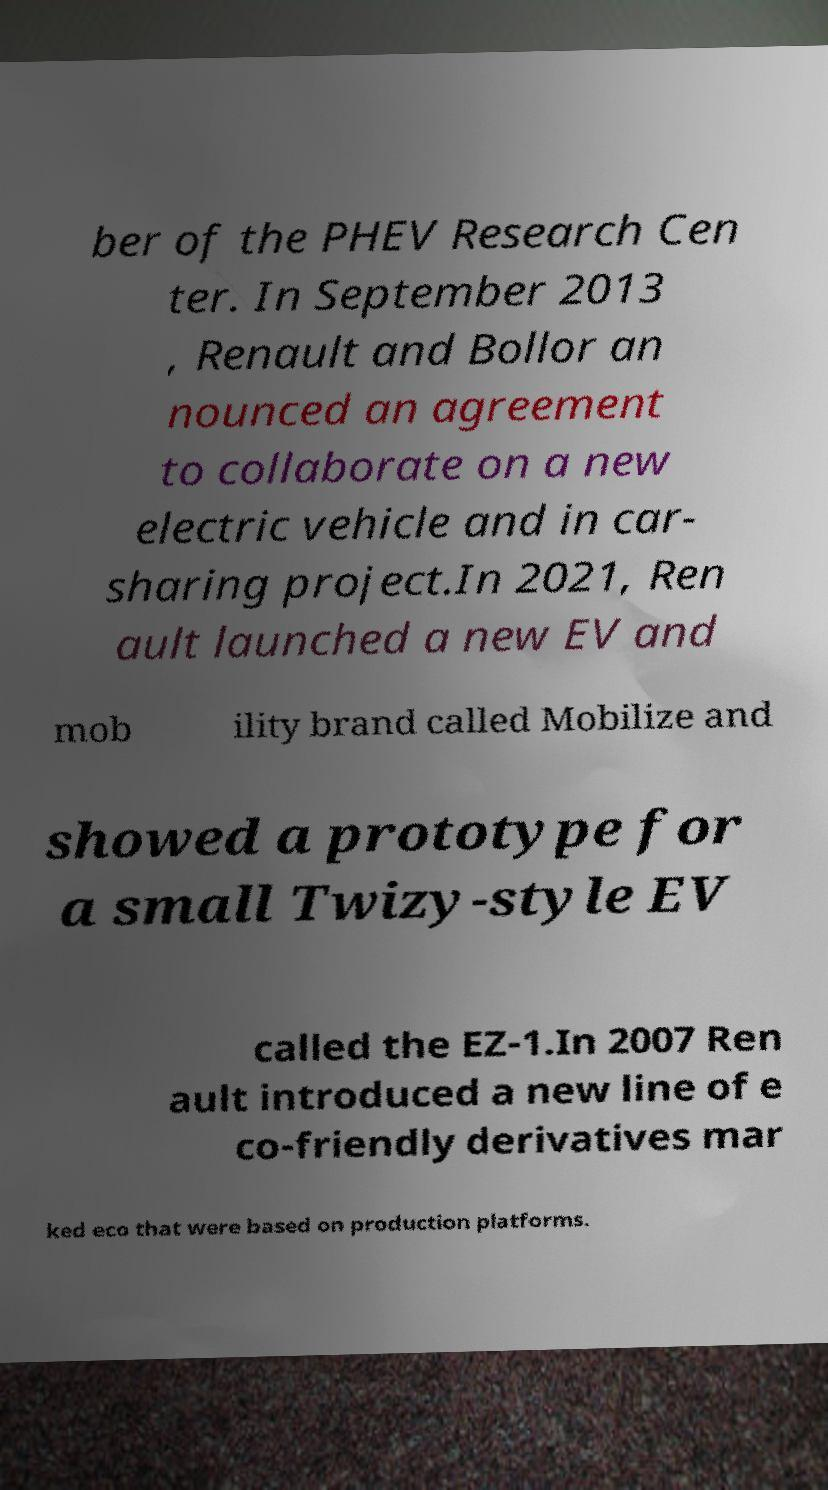Please read and relay the text visible in this image. What does it say? ber of the PHEV Research Cen ter. In September 2013 , Renault and Bollor an nounced an agreement to collaborate on a new electric vehicle and in car- sharing project.In 2021, Ren ault launched a new EV and mob ility brand called Mobilize and showed a prototype for a small Twizy-style EV called the EZ-1.In 2007 Ren ault introduced a new line of e co-friendly derivatives mar ked eco that were based on production platforms. 